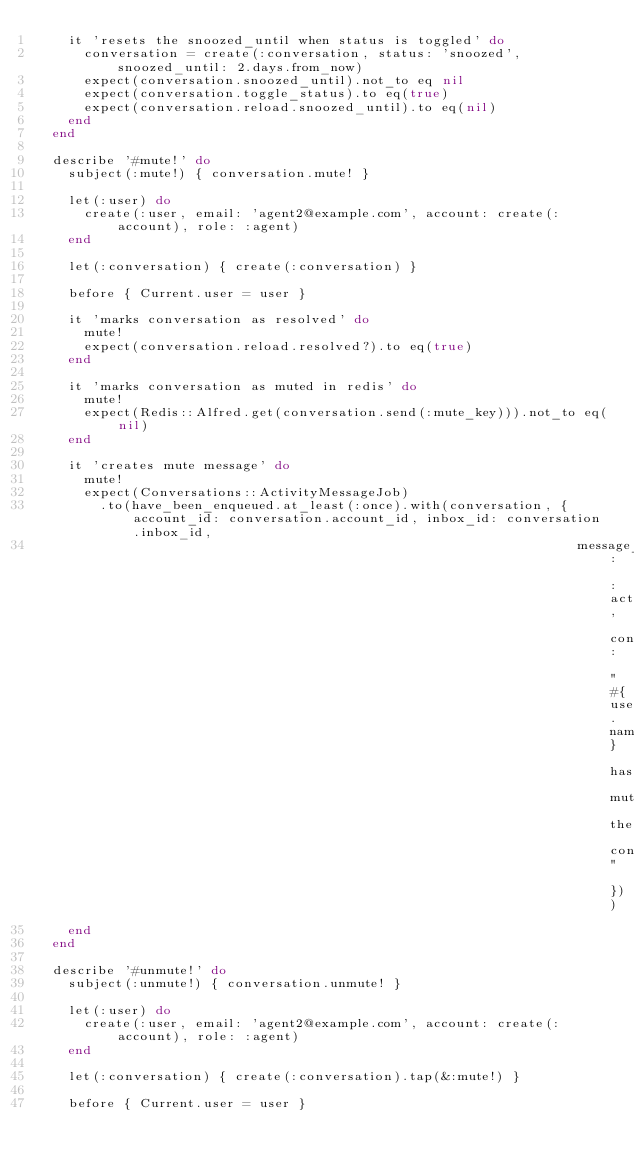<code> <loc_0><loc_0><loc_500><loc_500><_Ruby_>    it 'resets the snoozed_until when status is toggled' do
      conversation = create(:conversation, status: 'snoozed', snoozed_until: 2.days.from_now)
      expect(conversation.snoozed_until).not_to eq nil
      expect(conversation.toggle_status).to eq(true)
      expect(conversation.reload.snoozed_until).to eq(nil)
    end
  end

  describe '#mute!' do
    subject(:mute!) { conversation.mute! }

    let(:user) do
      create(:user, email: 'agent2@example.com', account: create(:account), role: :agent)
    end

    let(:conversation) { create(:conversation) }

    before { Current.user = user }

    it 'marks conversation as resolved' do
      mute!
      expect(conversation.reload.resolved?).to eq(true)
    end

    it 'marks conversation as muted in redis' do
      mute!
      expect(Redis::Alfred.get(conversation.send(:mute_key))).not_to eq(nil)
    end

    it 'creates mute message' do
      mute!
      expect(Conversations::ActivityMessageJob)
        .to(have_been_enqueued.at_least(:once).with(conversation, { account_id: conversation.account_id, inbox_id: conversation.inbox_id,
                                                                    message_type: :activity, content: "#{user.name} has muted the conversation" }))
    end
  end

  describe '#unmute!' do
    subject(:unmute!) { conversation.unmute! }

    let(:user) do
      create(:user, email: 'agent2@example.com', account: create(:account), role: :agent)
    end

    let(:conversation) { create(:conversation).tap(&:mute!) }

    before { Current.user = user }
</code> 